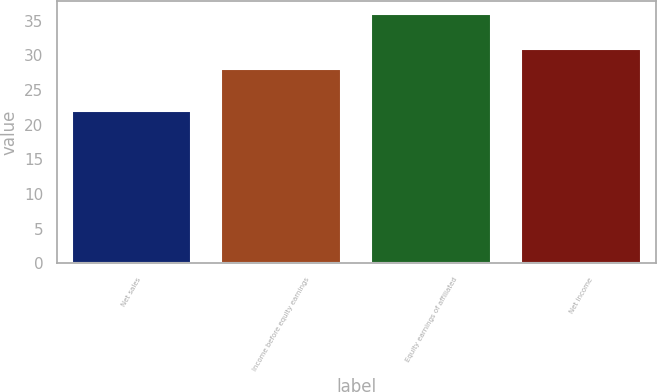<chart> <loc_0><loc_0><loc_500><loc_500><bar_chart><fcel>Net sales<fcel>Income before equity earnings<fcel>Equity earnings of affiliated<fcel>Net income<nl><fcel>22<fcel>28<fcel>36<fcel>31<nl></chart> 